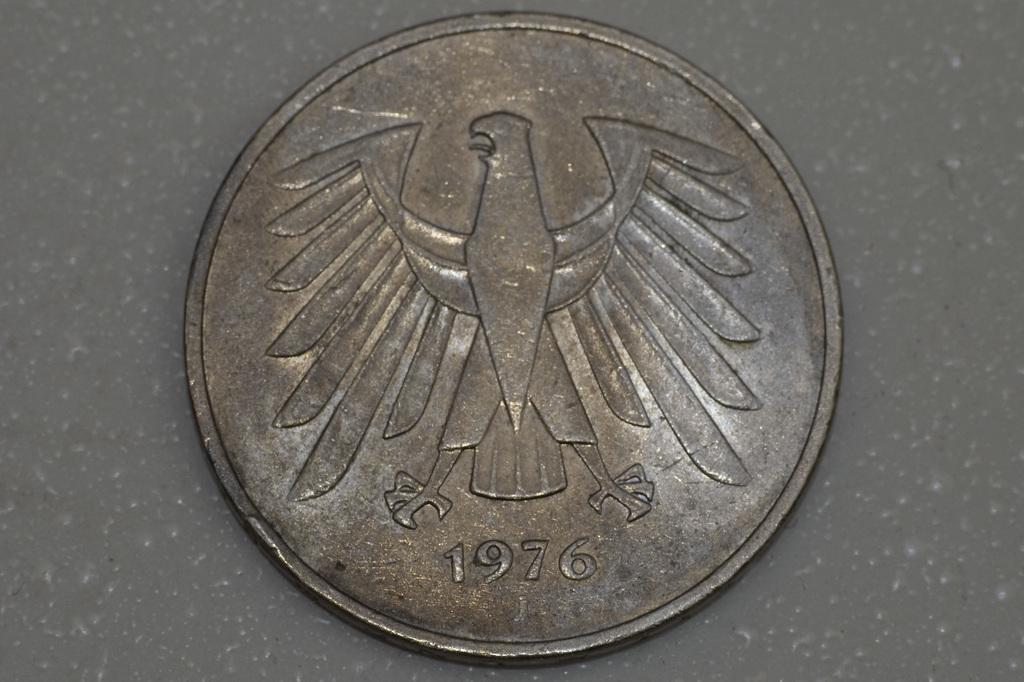What year is this coin from?
Keep it short and to the point. 1976. 